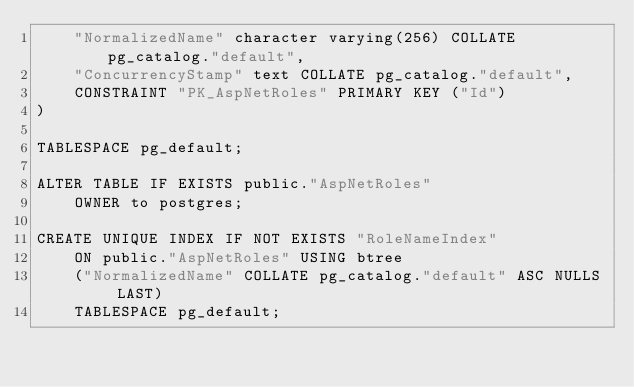Convert code to text. <code><loc_0><loc_0><loc_500><loc_500><_SQL_>    "NormalizedName" character varying(256) COLLATE pg_catalog."default",
    "ConcurrencyStamp" text COLLATE pg_catalog."default",
    CONSTRAINT "PK_AspNetRoles" PRIMARY KEY ("Id")
)

TABLESPACE pg_default;

ALTER TABLE IF EXISTS public."AspNetRoles"
    OWNER to postgres;

CREATE UNIQUE INDEX IF NOT EXISTS "RoleNameIndex"
    ON public."AspNetRoles" USING btree
    ("NormalizedName" COLLATE pg_catalog."default" ASC NULLS LAST)
    TABLESPACE pg_default;
	</code> 